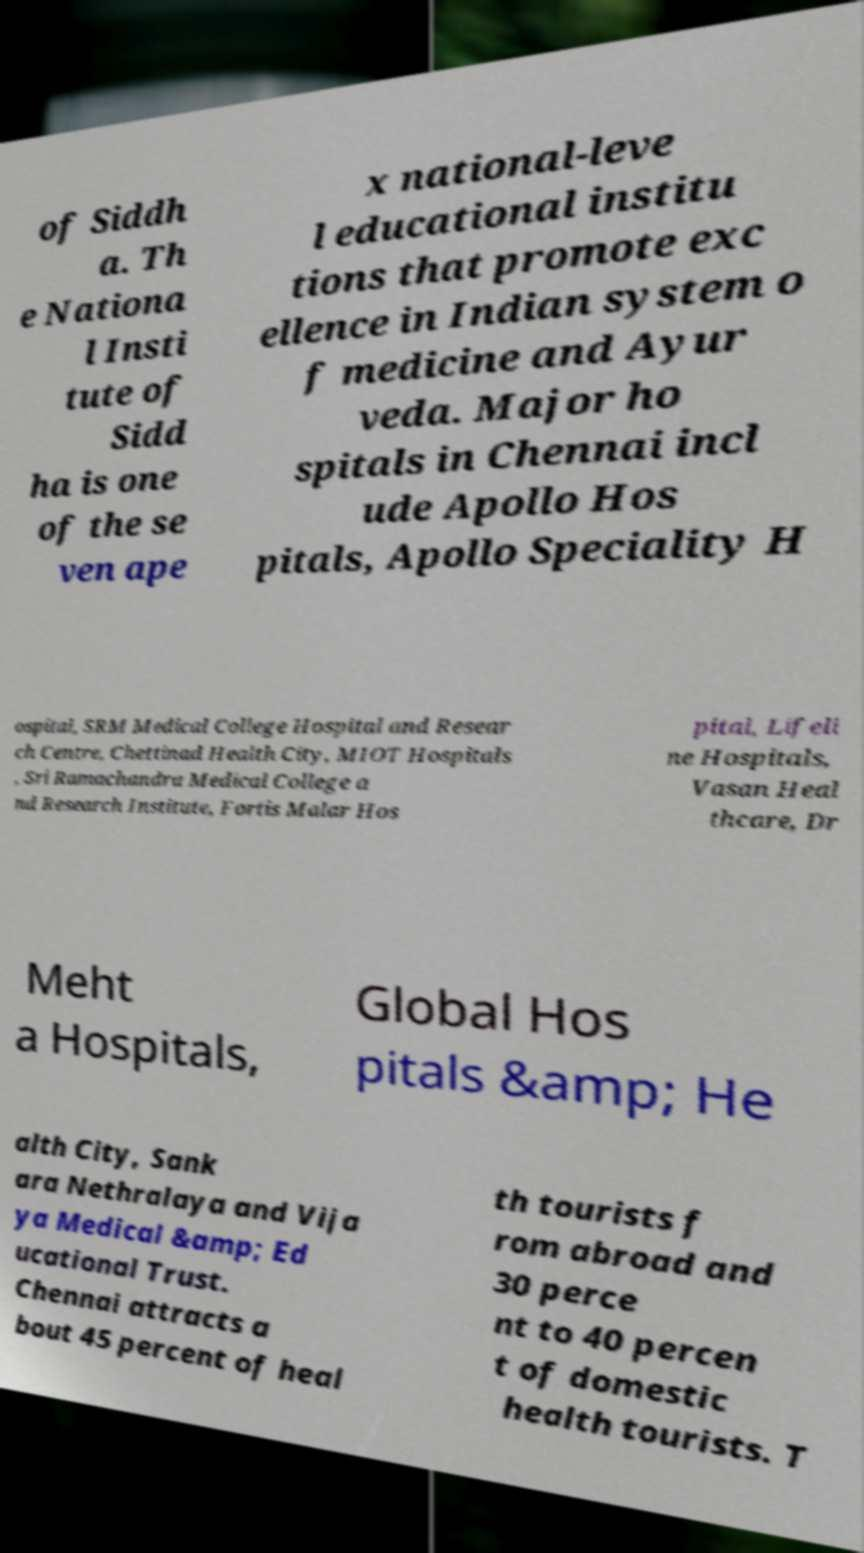Please read and relay the text visible in this image. What does it say? of Siddh a. Th e Nationa l Insti tute of Sidd ha is one of the se ven ape x national-leve l educational institu tions that promote exc ellence in Indian system o f medicine and Ayur veda. Major ho spitals in Chennai incl ude Apollo Hos pitals, Apollo Speciality H ospital, SRM Medical College Hospital and Resear ch Centre, Chettinad Health City, MIOT Hospitals , Sri Ramachandra Medical College a nd Research Institute, Fortis Malar Hos pital, Lifeli ne Hospitals, Vasan Heal thcare, Dr Meht a Hospitals, Global Hos pitals &amp; He alth City, Sank ara Nethralaya and Vija ya Medical &amp; Ed ucational Trust. Chennai attracts a bout 45 percent of heal th tourists f rom abroad and 30 perce nt to 40 percen t of domestic health tourists. T 